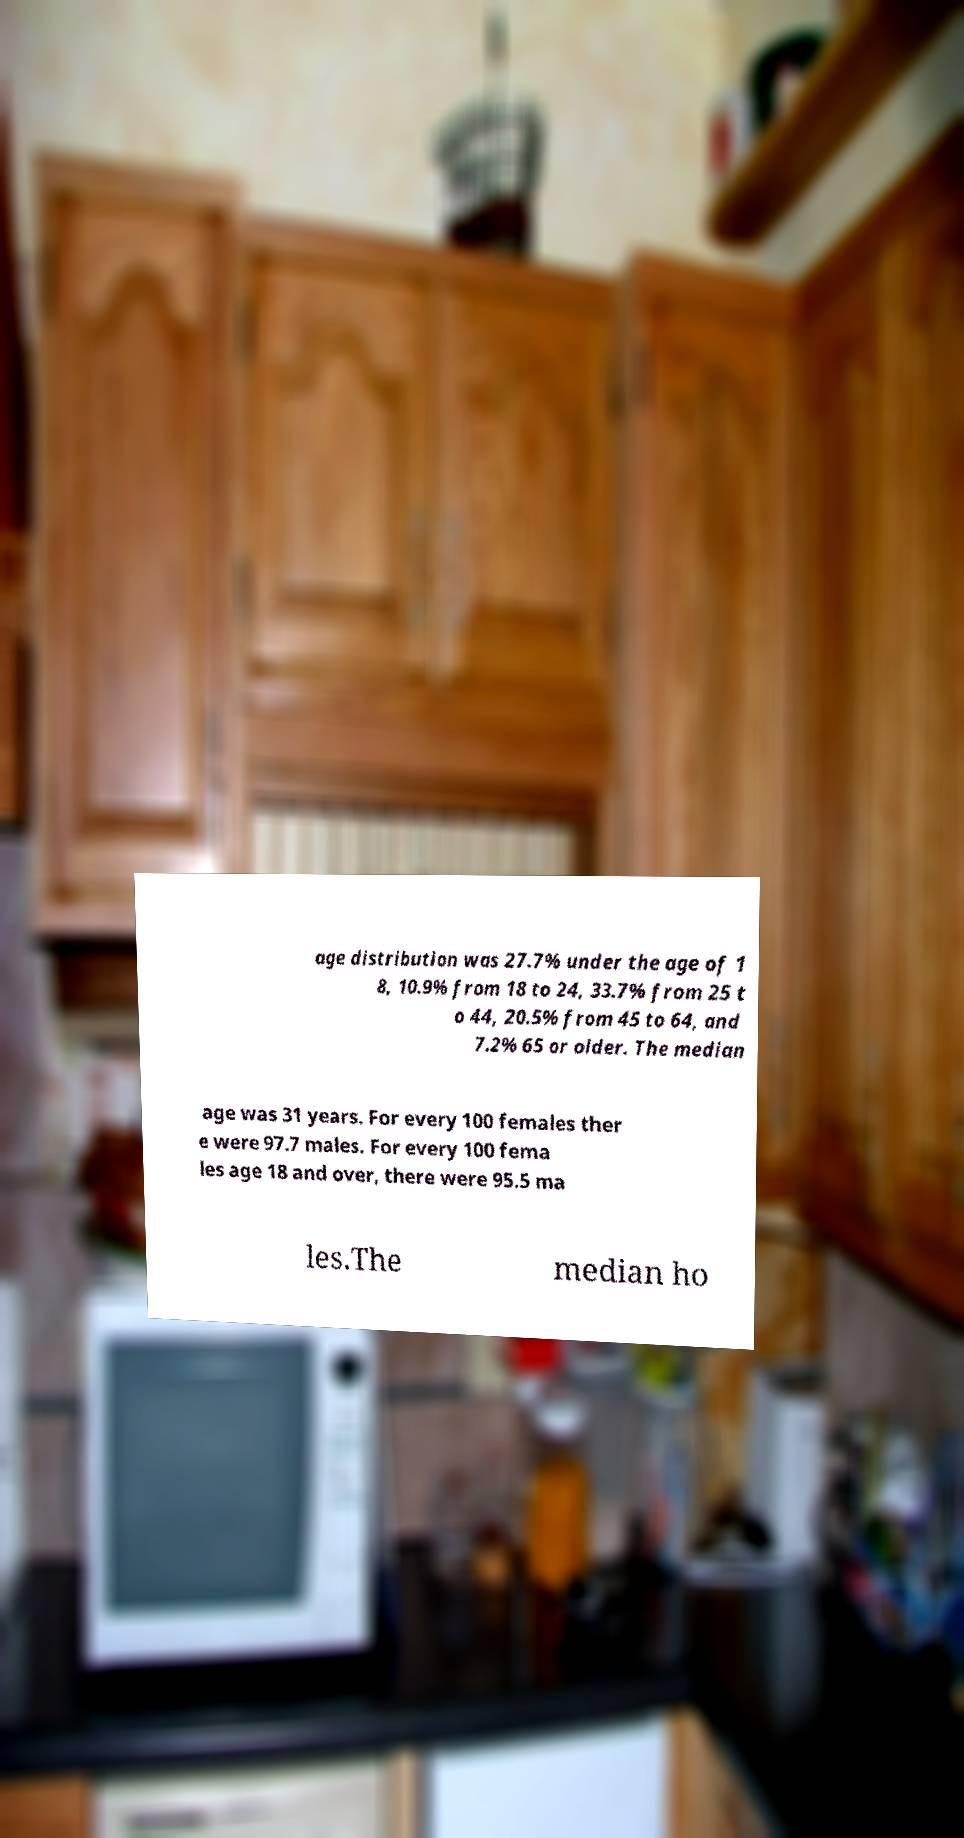Can you accurately transcribe the text from the provided image for me? age distribution was 27.7% under the age of 1 8, 10.9% from 18 to 24, 33.7% from 25 t o 44, 20.5% from 45 to 64, and 7.2% 65 or older. The median age was 31 years. For every 100 females ther e were 97.7 males. For every 100 fema les age 18 and over, there were 95.5 ma les.The median ho 